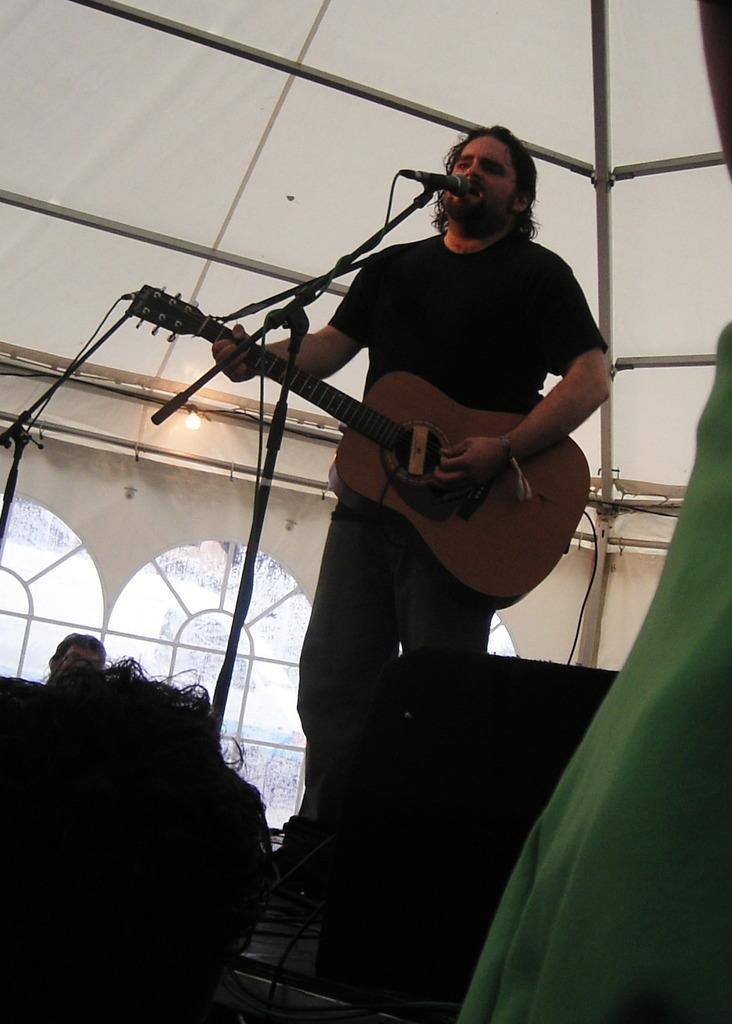What is the main subject of the image? There is a person standing at the center of the image. What is the person holding in his hand? The person is holding a guitar in his hand. What is the person doing with the guitar? The person is singing while holding the guitar. Can you describe the other person in the image? There is a man on the left side of the image. What type of cough does the person have while playing the guitar in the image? There is no indication of a cough in the image; the person is singing while holding the guitar. What innovative idea does the expert on the right side of the image have? There is no expert or innovative idea mentioned in the image; it only features a person playing the guitar and another person on the left side. 